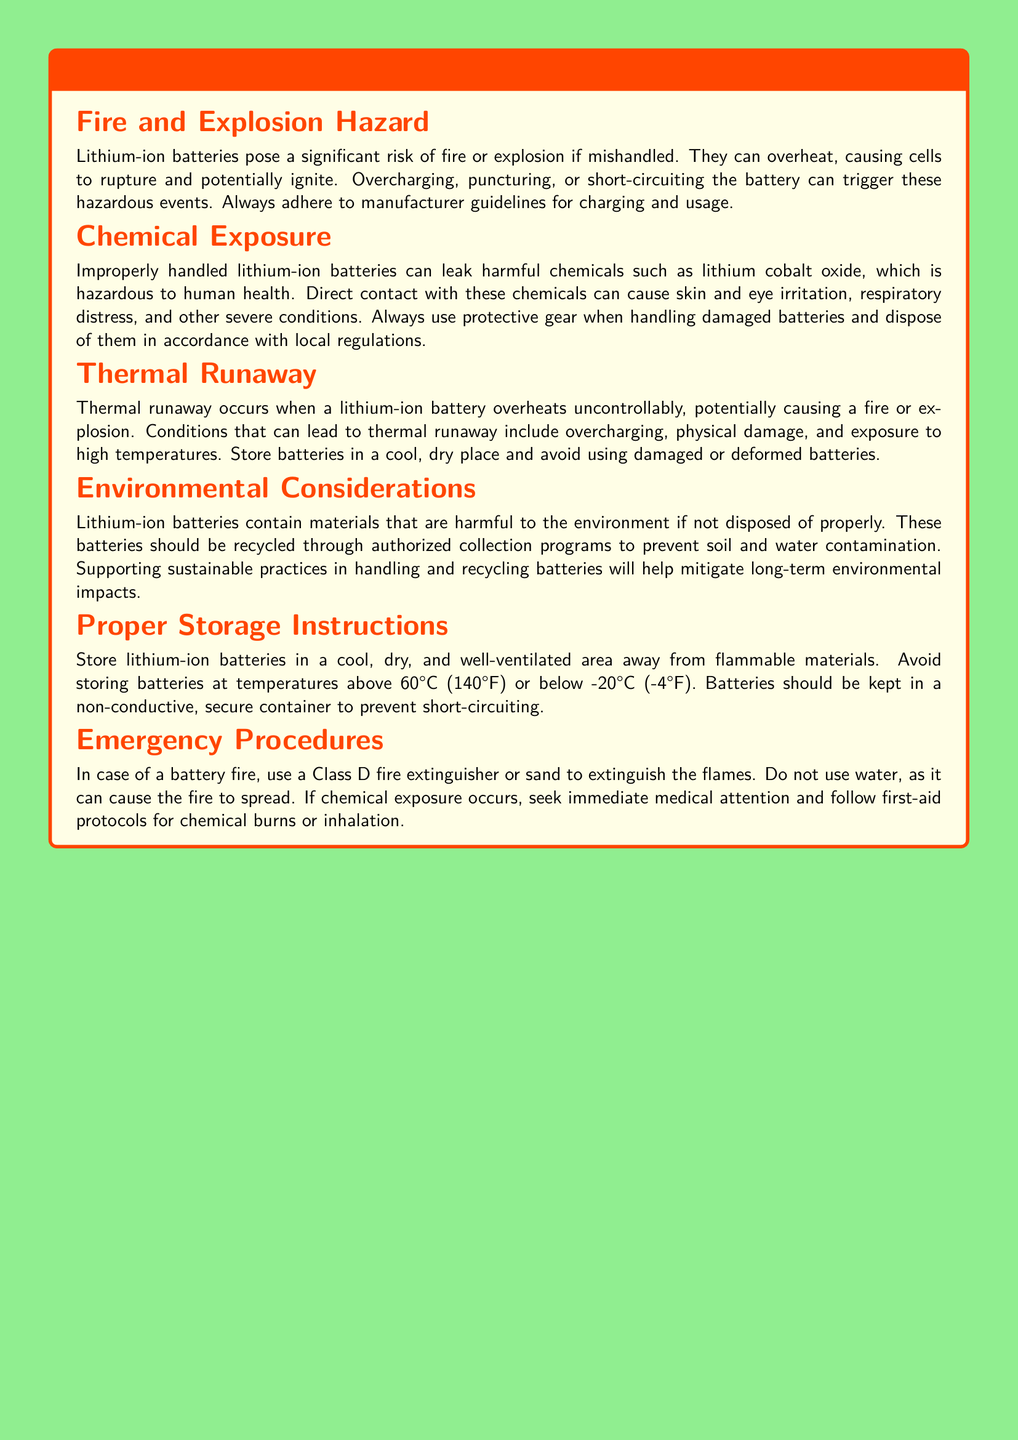What is the main fire hazard associated with lithium-ion batteries? The document states that the main fire hazard is that lithium-ion batteries can overheat, causing cells to rupture and potentially ignite.
Answer: Overheating What materials can leak from improperly handled batteries? It indicates that lithium cobalt oxide can leak, which is hazardous to human health.
Answer: Lithium cobalt oxide At what temperature should batteries not be stored above? The document specifies that batteries should not be stored at temperatures above 60°C.
Answer: 60°C What should be used to extinguish a battery fire? The document advises using a Class D fire extinguisher or sand to extinguish the flames.
Answer: Class D fire extinguisher What condition can cause thermal runaway in lithium-ion batteries? It details that overcharging is one of the conditions that can lead to thermal runaway.
Answer: Overcharging What type of environment is recommended for battery storage? The document suggests storing batteries in a cool, dry, and well-ventilated area.
Answer: Cool, dry, well-ventilated What should you do if chemical exposure occurs? It indicates that one should seek immediate medical attention and follow first-aid protocols for chemical burns or inhalation.
Answer: Seek immediate medical attention Which color is used for the warning label title? The document describes the title color as warning red.
Answer: Warning red What kind of programs should recycling of lithium-ion batteries be done through? The document states that recycling should be done through authorized collection programs.
Answer: Authorized collection programs 